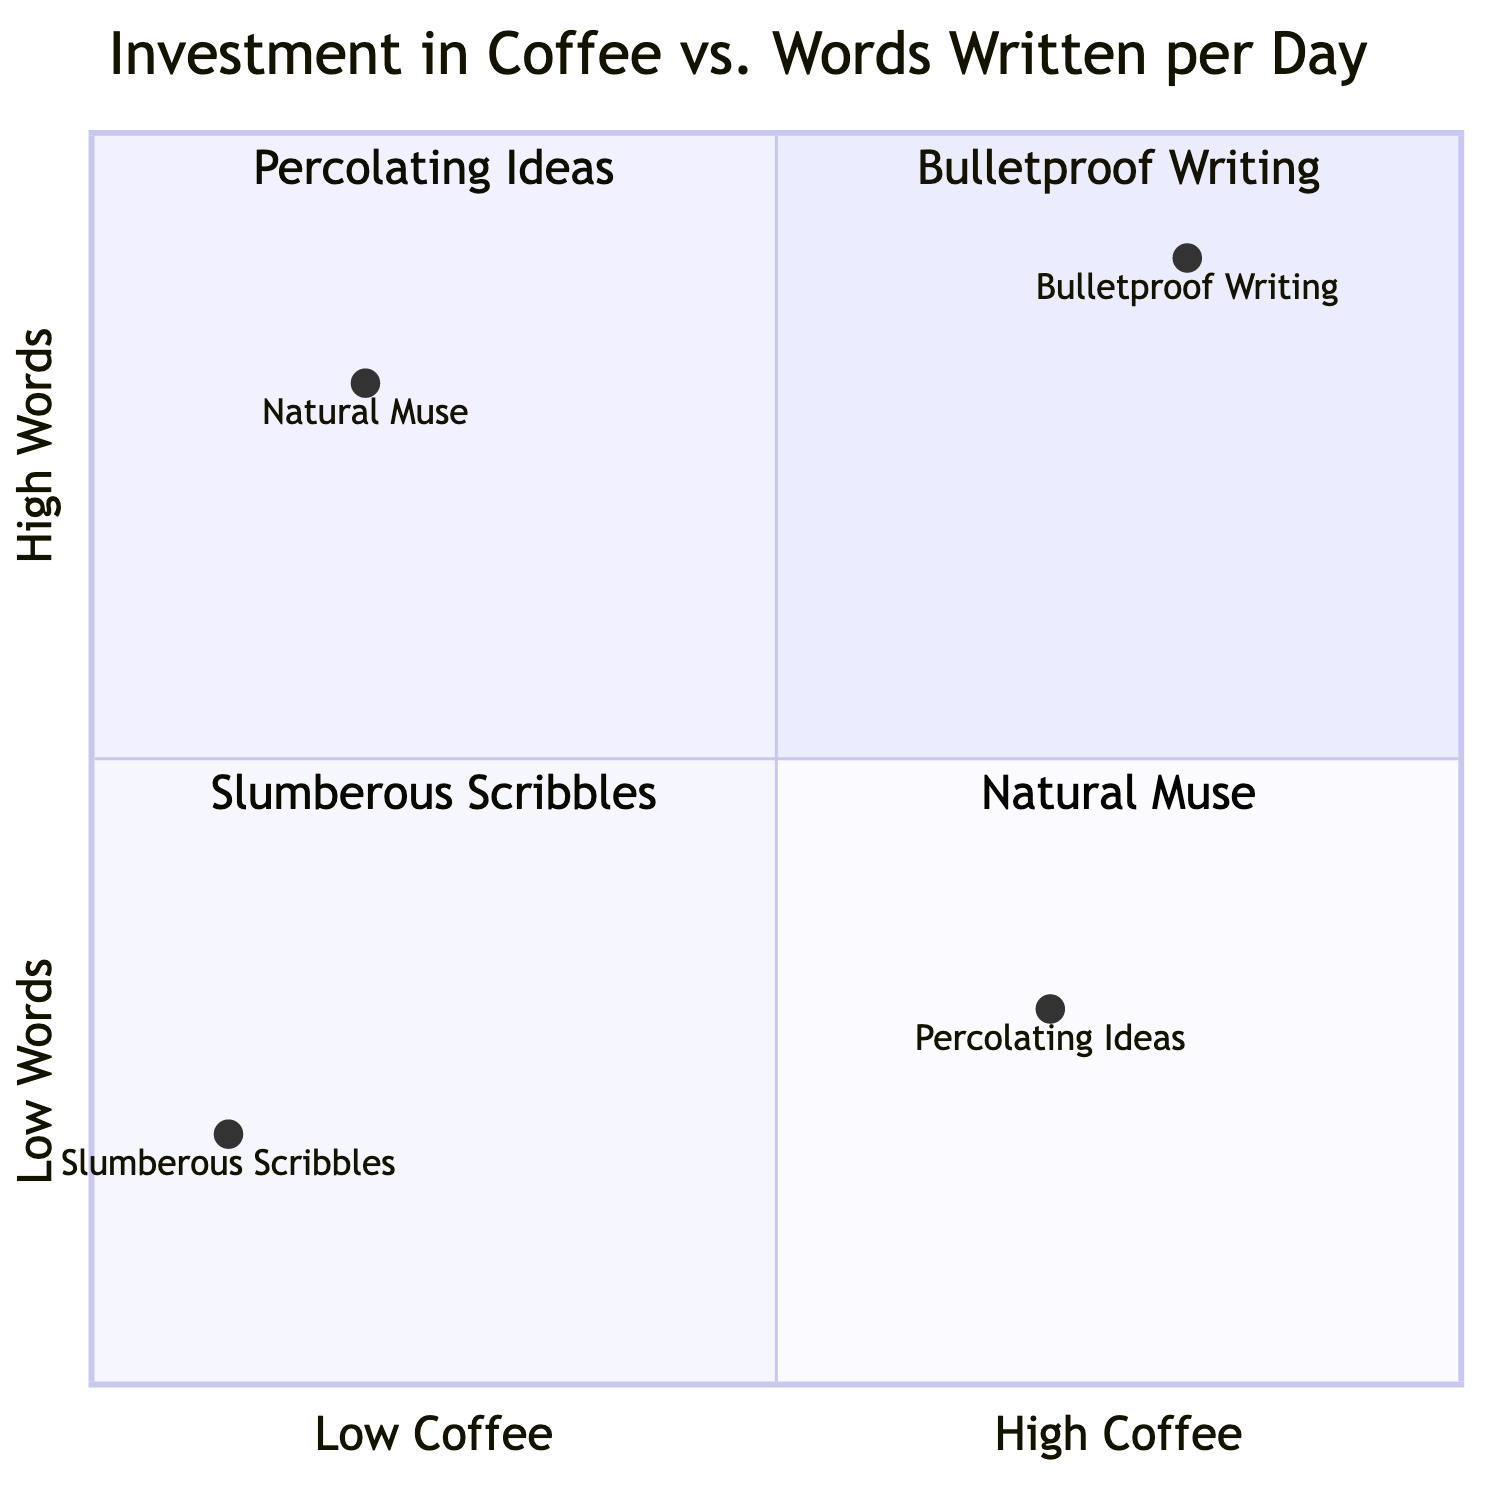What is the label of the top right quadrant? The top right quadrant corresponds to high coffee consumption and high words written per day. According to the data, this quadrant is labeled "Bulletproof Writing."
Answer: Bulletproof Writing Which quadrant has the lowest words written per day? To determine which quadrant has the lowest words written per day, we look at the y-axis where low words are indicated. The quadrant in the bottom left is labeled "Slumberous Scribbles," which reflects low coffee and low words.
Answer: Slumberous Scribbles How many total quadrants are in the diagram? The diagram is structured into four quadrants, as indicated by the sections defined in the data. Each quadrant represents a unique combination of coffee consumption and words written.
Answer: Four What is the example output for "Natural Muse"? The example for "Natural Muse" explicitly describes the type of content produced in this quadrant. It states that the output includes witty satire with a touch of engineering marvels.
Answer: Witty satire with a touch of engineering marvels Which quadrant contains "Percolating Ideas"? "Percolating Ideas" is positioned in the bottom right quadrant, which is defined by high coffee consumption and low words written. This quadrant contrasts with the other quadrants in terms of its output focus.
Answer: Percolating Ideas What type of writing is associated with "Slumberous Scribbles"? In the description provided for "Slumberous Scribbles," the associated type of writing is described as sparse and lethargic, indicating a lack of energy in the articles produced.
Answer: Sparse, somewhat lethargic articles What relationship exists between "Bulletproof Writing" and coffee? "Bulletproof Writing" is characterized by high coffee consumption, specifically mentioning artisanal espresso shots, indicating a positive correlation between coffee and writing output.
Answer: High coffee consumption In which quadrant would you find the highest coffee intake? The highest coffee intake is found in the top right quadrant, which is labeled "Bulletproof Writing". This indicates that those in this quadrant consume significant amounts of coffee.
Answer: Bulletproof Writing 